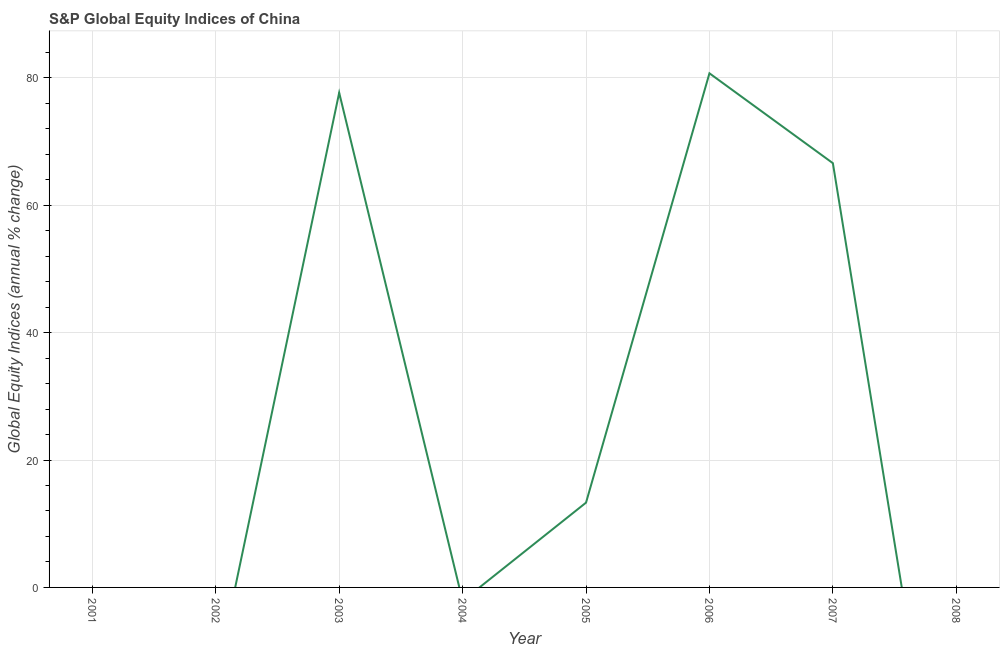What is the s&p global equity indices in 2001?
Keep it short and to the point. 0. Across all years, what is the maximum s&p global equity indices?
Offer a very short reply. 80.72. In which year was the s&p global equity indices maximum?
Provide a short and direct response. 2006. What is the sum of the s&p global equity indices?
Your answer should be compact. 238.31. What is the average s&p global equity indices per year?
Offer a terse response. 29.79. What is the median s&p global equity indices?
Your answer should be compact. 6.66. What is the ratio of the s&p global equity indices in 2003 to that in 2005?
Provide a short and direct response. 5.83. What is the difference between the highest and the second highest s&p global equity indices?
Offer a very short reply. 3.05. Is the sum of the s&p global equity indices in 2005 and 2007 greater than the maximum s&p global equity indices across all years?
Provide a short and direct response. No. What is the difference between the highest and the lowest s&p global equity indices?
Keep it short and to the point. 80.72. Does the s&p global equity indices monotonically increase over the years?
Your answer should be very brief. No. How many lines are there?
Keep it short and to the point. 1. How many years are there in the graph?
Your answer should be compact. 8. What is the difference between two consecutive major ticks on the Y-axis?
Provide a succinct answer. 20. What is the title of the graph?
Your response must be concise. S&P Global Equity Indices of China. What is the label or title of the X-axis?
Give a very brief answer. Year. What is the label or title of the Y-axis?
Offer a very short reply. Global Equity Indices (annual % change). What is the Global Equity Indices (annual % change) in 2001?
Make the answer very short. 0. What is the Global Equity Indices (annual % change) of 2002?
Offer a very short reply. 0. What is the Global Equity Indices (annual % change) in 2003?
Your answer should be very brief. 77.67. What is the Global Equity Indices (annual % change) of 2005?
Give a very brief answer. 13.31. What is the Global Equity Indices (annual % change) of 2006?
Keep it short and to the point. 80.72. What is the Global Equity Indices (annual % change) of 2007?
Provide a succinct answer. 66.61. What is the difference between the Global Equity Indices (annual % change) in 2003 and 2005?
Offer a very short reply. 64.36. What is the difference between the Global Equity Indices (annual % change) in 2003 and 2006?
Make the answer very short. -3.05. What is the difference between the Global Equity Indices (annual % change) in 2003 and 2007?
Give a very brief answer. 11.06. What is the difference between the Global Equity Indices (annual % change) in 2005 and 2006?
Offer a very short reply. -67.41. What is the difference between the Global Equity Indices (annual % change) in 2005 and 2007?
Your response must be concise. -53.3. What is the difference between the Global Equity Indices (annual % change) in 2006 and 2007?
Offer a very short reply. 14.11. What is the ratio of the Global Equity Indices (annual % change) in 2003 to that in 2005?
Keep it short and to the point. 5.83. What is the ratio of the Global Equity Indices (annual % change) in 2003 to that in 2006?
Offer a very short reply. 0.96. What is the ratio of the Global Equity Indices (annual % change) in 2003 to that in 2007?
Provide a succinct answer. 1.17. What is the ratio of the Global Equity Indices (annual % change) in 2005 to that in 2006?
Provide a short and direct response. 0.17. What is the ratio of the Global Equity Indices (annual % change) in 2006 to that in 2007?
Give a very brief answer. 1.21. 